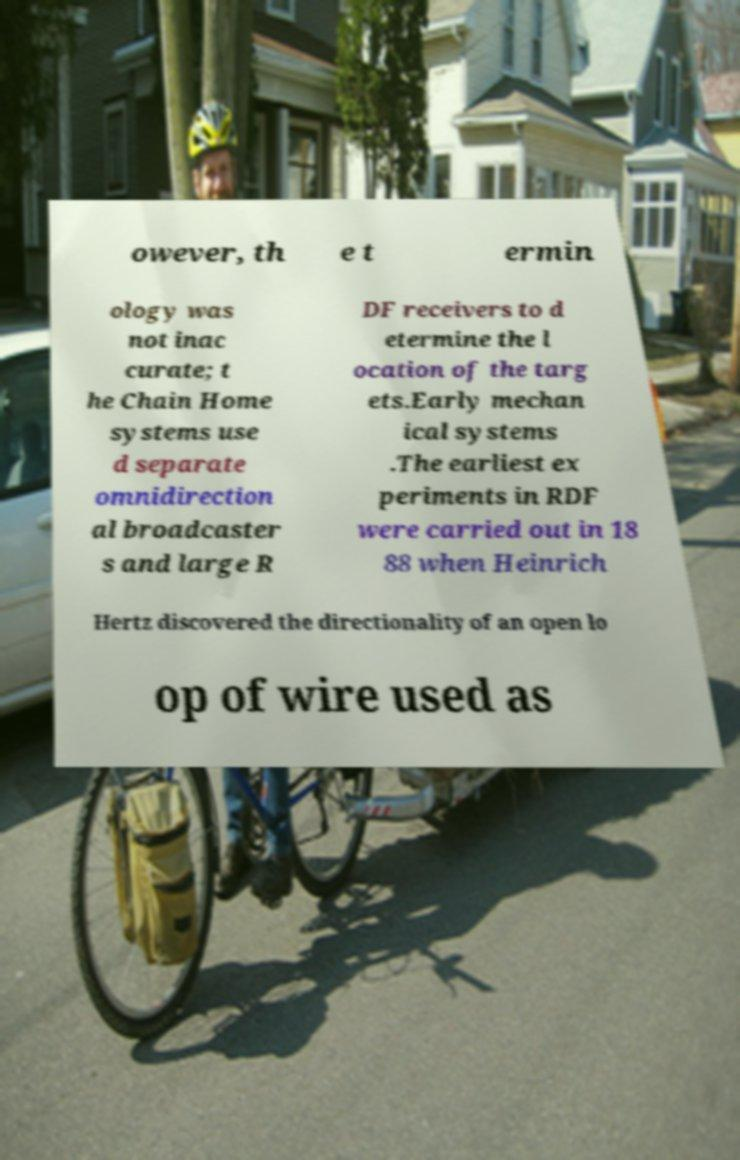Please read and relay the text visible in this image. What does it say? owever, th e t ermin ology was not inac curate; t he Chain Home systems use d separate omnidirection al broadcaster s and large R DF receivers to d etermine the l ocation of the targ ets.Early mechan ical systems .The earliest ex periments in RDF were carried out in 18 88 when Heinrich Hertz discovered the directionality of an open lo op of wire used as 